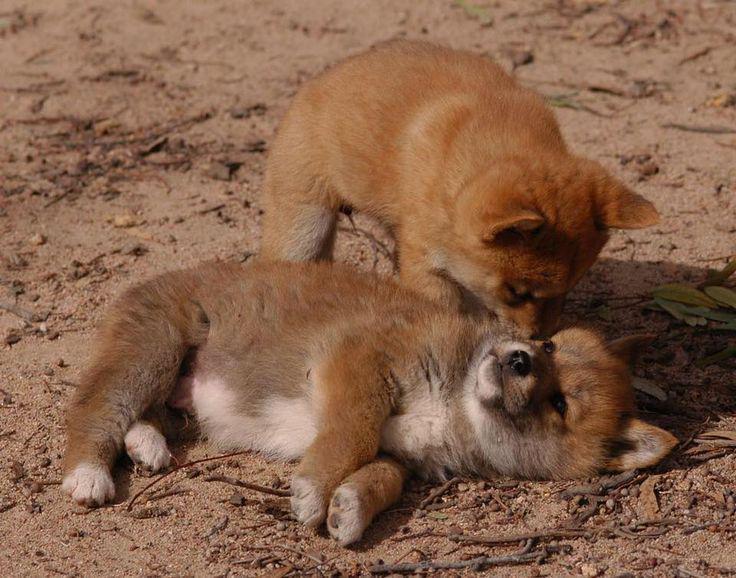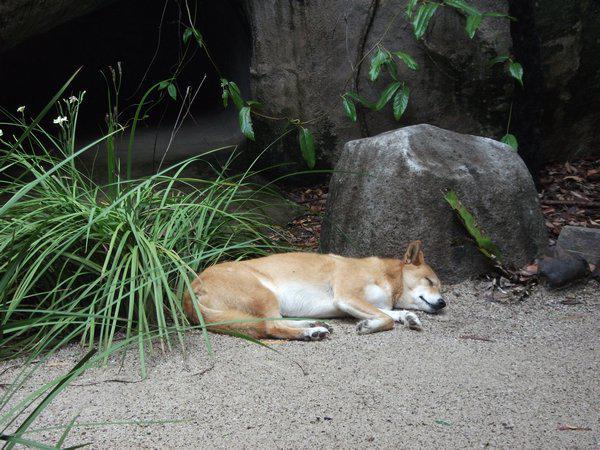The first image is the image on the left, the second image is the image on the right. Given the left and right images, does the statement "The left image contains exactly two wild dogs." hold true? Answer yes or no. Yes. The first image is the image on the left, the second image is the image on the right. Evaluate the accuracy of this statement regarding the images: "An image includes an adult dingo that is not lying with its head on the ground.". Is it true? Answer yes or no. No. 